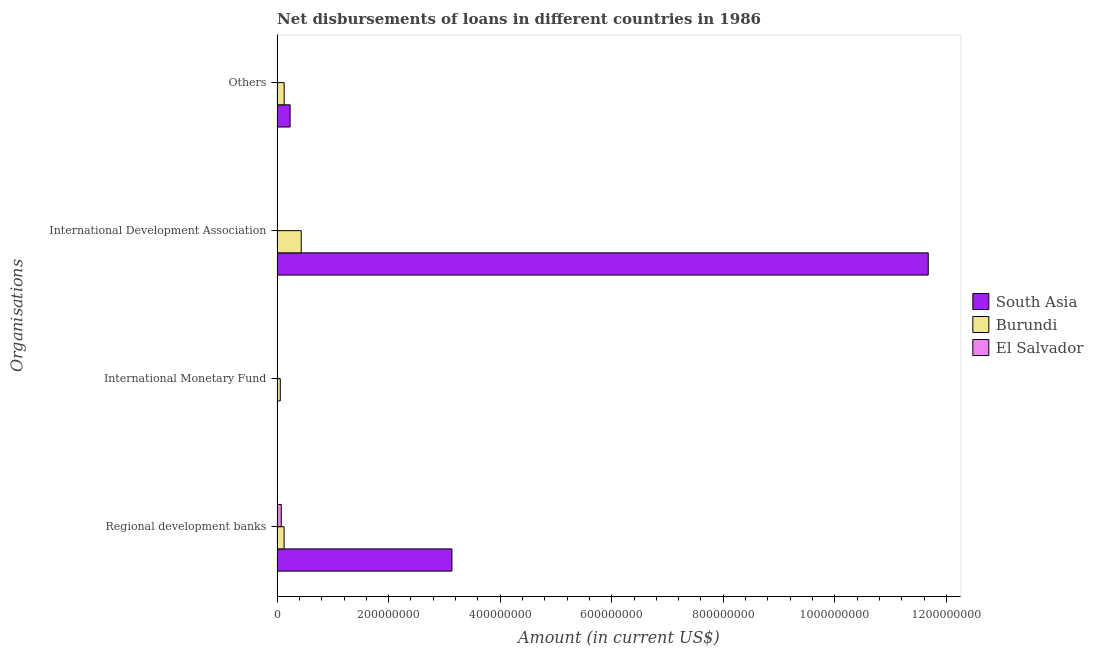How many different coloured bars are there?
Make the answer very short. 3. Are the number of bars per tick equal to the number of legend labels?
Your answer should be compact. No. How many bars are there on the 3rd tick from the top?
Your response must be concise. 1. How many bars are there on the 4th tick from the bottom?
Your answer should be compact. 2. What is the label of the 2nd group of bars from the top?
Make the answer very short. International Development Association. Across all countries, what is the maximum amount of loan disimbursed by international monetary fund?
Offer a terse response. 5.68e+06. Across all countries, what is the minimum amount of loan disimbursed by international monetary fund?
Keep it short and to the point. 0. In which country was the amount of loan disimbursed by international monetary fund maximum?
Keep it short and to the point. Burundi. What is the total amount of loan disimbursed by other organisations in the graph?
Give a very brief answer. 3.59e+07. What is the difference between the amount of loan disimbursed by international development association in South Asia and that in Burundi?
Give a very brief answer. 1.12e+09. What is the difference between the amount of loan disimbursed by international development association in El Salvador and the amount of loan disimbursed by regional development banks in South Asia?
Your response must be concise. -3.13e+08. What is the average amount of loan disimbursed by regional development banks per country?
Provide a succinct answer. 1.11e+08. What is the difference between the amount of loan disimbursed by other organisations and amount of loan disimbursed by regional development banks in Burundi?
Your response must be concise. 1.04e+05. What is the ratio of the amount of loan disimbursed by international development association in Burundi to that in South Asia?
Your response must be concise. 0.04. What is the difference between the highest and the lowest amount of loan disimbursed by regional development banks?
Offer a terse response. 3.06e+08. In how many countries, is the amount of loan disimbursed by regional development banks greater than the average amount of loan disimbursed by regional development banks taken over all countries?
Ensure brevity in your answer.  1. Is the sum of the amount of loan disimbursed by regional development banks in El Salvador and Burundi greater than the maximum amount of loan disimbursed by other organisations across all countries?
Your response must be concise. No. Is it the case that in every country, the sum of the amount of loan disimbursed by international monetary fund and amount of loan disimbursed by regional development banks is greater than the sum of amount of loan disimbursed by other organisations and amount of loan disimbursed by international development association?
Provide a succinct answer. No. Is it the case that in every country, the sum of the amount of loan disimbursed by regional development banks and amount of loan disimbursed by international monetary fund is greater than the amount of loan disimbursed by international development association?
Your response must be concise. No. Are all the bars in the graph horizontal?
Offer a terse response. Yes. How many countries are there in the graph?
Offer a very short reply. 3. Are the values on the major ticks of X-axis written in scientific E-notation?
Provide a short and direct response. No. Where does the legend appear in the graph?
Offer a very short reply. Center right. How many legend labels are there?
Your answer should be very brief. 3. What is the title of the graph?
Provide a succinct answer. Net disbursements of loans in different countries in 1986. Does "Lebanon" appear as one of the legend labels in the graph?
Offer a very short reply. No. What is the label or title of the X-axis?
Your answer should be compact. Amount (in current US$). What is the label or title of the Y-axis?
Your response must be concise. Organisations. What is the Amount (in current US$) of South Asia in Regional development banks?
Offer a terse response. 3.13e+08. What is the Amount (in current US$) in Burundi in Regional development banks?
Your answer should be compact. 1.25e+07. What is the Amount (in current US$) in El Salvador in Regional development banks?
Your answer should be very brief. 7.46e+06. What is the Amount (in current US$) of Burundi in International Monetary Fund?
Make the answer very short. 5.68e+06. What is the Amount (in current US$) of El Salvador in International Monetary Fund?
Offer a very short reply. 0. What is the Amount (in current US$) in South Asia in International Development Association?
Offer a very short reply. 1.17e+09. What is the Amount (in current US$) of Burundi in International Development Association?
Offer a very short reply. 4.32e+07. What is the Amount (in current US$) of El Salvador in International Development Association?
Keep it short and to the point. 0. What is the Amount (in current US$) of South Asia in Others?
Offer a very short reply. 2.33e+07. What is the Amount (in current US$) in Burundi in Others?
Provide a short and direct response. 1.26e+07. What is the Amount (in current US$) of El Salvador in Others?
Keep it short and to the point. 0. Across all Organisations, what is the maximum Amount (in current US$) in South Asia?
Your response must be concise. 1.17e+09. Across all Organisations, what is the maximum Amount (in current US$) in Burundi?
Ensure brevity in your answer.  4.32e+07. Across all Organisations, what is the maximum Amount (in current US$) of El Salvador?
Offer a very short reply. 7.46e+06. Across all Organisations, what is the minimum Amount (in current US$) of South Asia?
Your answer should be very brief. 0. Across all Organisations, what is the minimum Amount (in current US$) in Burundi?
Provide a short and direct response. 5.68e+06. What is the total Amount (in current US$) of South Asia in the graph?
Your response must be concise. 1.50e+09. What is the total Amount (in current US$) of Burundi in the graph?
Keep it short and to the point. 7.40e+07. What is the total Amount (in current US$) of El Salvador in the graph?
Your response must be concise. 7.46e+06. What is the difference between the Amount (in current US$) of Burundi in Regional development banks and that in International Monetary Fund?
Make the answer very short. 6.83e+06. What is the difference between the Amount (in current US$) of South Asia in Regional development banks and that in International Development Association?
Provide a short and direct response. -8.54e+08. What is the difference between the Amount (in current US$) in Burundi in Regional development banks and that in International Development Association?
Offer a terse response. -3.07e+07. What is the difference between the Amount (in current US$) in South Asia in Regional development banks and that in Others?
Your answer should be compact. 2.90e+08. What is the difference between the Amount (in current US$) in Burundi in Regional development banks and that in Others?
Your answer should be compact. -1.04e+05. What is the difference between the Amount (in current US$) in Burundi in International Monetary Fund and that in International Development Association?
Your answer should be very brief. -3.75e+07. What is the difference between the Amount (in current US$) in Burundi in International Monetary Fund and that in Others?
Ensure brevity in your answer.  -6.93e+06. What is the difference between the Amount (in current US$) in South Asia in International Development Association and that in Others?
Provide a succinct answer. 1.14e+09. What is the difference between the Amount (in current US$) in Burundi in International Development Association and that in Others?
Make the answer very short. 3.06e+07. What is the difference between the Amount (in current US$) of South Asia in Regional development banks and the Amount (in current US$) of Burundi in International Monetary Fund?
Give a very brief answer. 3.08e+08. What is the difference between the Amount (in current US$) of South Asia in Regional development banks and the Amount (in current US$) of Burundi in International Development Association?
Make the answer very short. 2.70e+08. What is the difference between the Amount (in current US$) of South Asia in Regional development banks and the Amount (in current US$) of Burundi in Others?
Ensure brevity in your answer.  3.01e+08. What is the difference between the Amount (in current US$) in South Asia in International Development Association and the Amount (in current US$) in Burundi in Others?
Make the answer very short. 1.15e+09. What is the average Amount (in current US$) in South Asia per Organisations?
Keep it short and to the point. 3.76e+08. What is the average Amount (in current US$) in Burundi per Organisations?
Make the answer very short. 1.85e+07. What is the average Amount (in current US$) of El Salvador per Organisations?
Provide a short and direct response. 1.87e+06. What is the difference between the Amount (in current US$) in South Asia and Amount (in current US$) in Burundi in Regional development banks?
Your answer should be compact. 3.01e+08. What is the difference between the Amount (in current US$) of South Asia and Amount (in current US$) of El Salvador in Regional development banks?
Your answer should be compact. 3.06e+08. What is the difference between the Amount (in current US$) of Burundi and Amount (in current US$) of El Salvador in Regional development banks?
Keep it short and to the point. 5.05e+06. What is the difference between the Amount (in current US$) of South Asia and Amount (in current US$) of Burundi in International Development Association?
Ensure brevity in your answer.  1.12e+09. What is the difference between the Amount (in current US$) of South Asia and Amount (in current US$) of Burundi in Others?
Offer a very short reply. 1.07e+07. What is the ratio of the Amount (in current US$) in Burundi in Regional development banks to that in International Monetary Fund?
Your response must be concise. 2.2. What is the ratio of the Amount (in current US$) of South Asia in Regional development banks to that in International Development Association?
Offer a terse response. 0.27. What is the ratio of the Amount (in current US$) of Burundi in Regional development banks to that in International Development Association?
Ensure brevity in your answer.  0.29. What is the ratio of the Amount (in current US$) in South Asia in Regional development banks to that in Others?
Provide a succinct answer. 13.47. What is the ratio of the Amount (in current US$) of Burundi in International Monetary Fund to that in International Development Association?
Your answer should be very brief. 0.13. What is the ratio of the Amount (in current US$) in Burundi in International Monetary Fund to that in Others?
Your answer should be very brief. 0.45. What is the ratio of the Amount (in current US$) of South Asia in International Development Association to that in Others?
Offer a very short reply. 50.18. What is the ratio of the Amount (in current US$) in Burundi in International Development Association to that in Others?
Your response must be concise. 3.43. What is the difference between the highest and the second highest Amount (in current US$) in South Asia?
Ensure brevity in your answer.  8.54e+08. What is the difference between the highest and the second highest Amount (in current US$) in Burundi?
Your response must be concise. 3.06e+07. What is the difference between the highest and the lowest Amount (in current US$) of South Asia?
Your answer should be very brief. 1.17e+09. What is the difference between the highest and the lowest Amount (in current US$) in Burundi?
Provide a succinct answer. 3.75e+07. What is the difference between the highest and the lowest Amount (in current US$) in El Salvador?
Make the answer very short. 7.46e+06. 